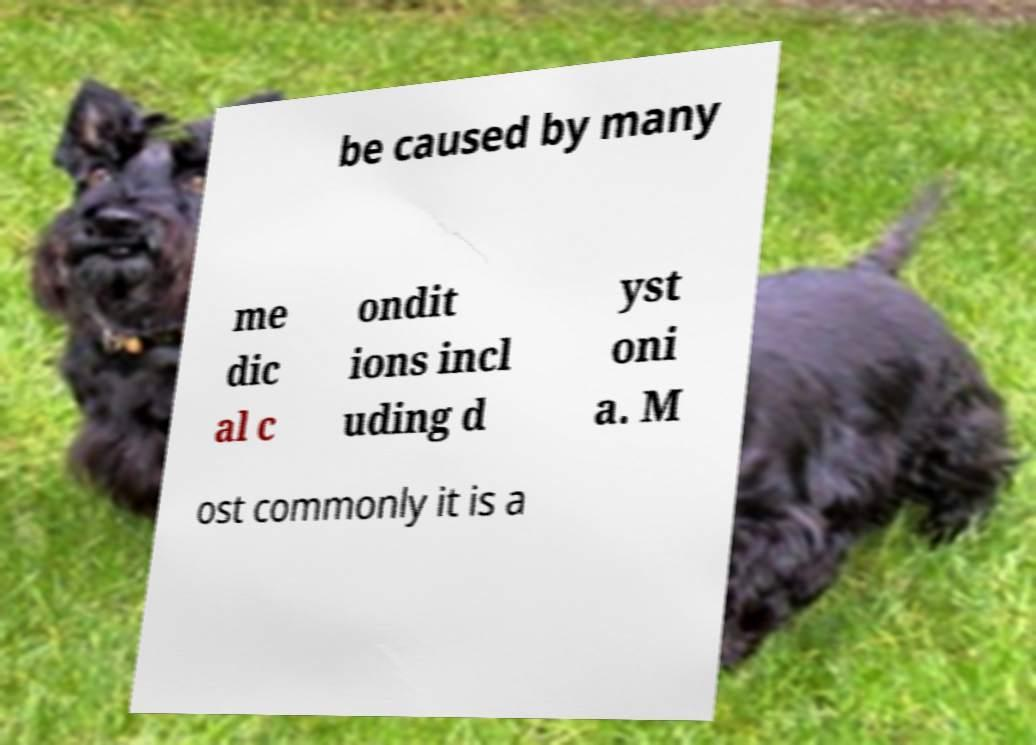Please read and relay the text visible in this image. What does it say? be caused by many me dic al c ondit ions incl uding d yst oni a. M ost commonly it is a 